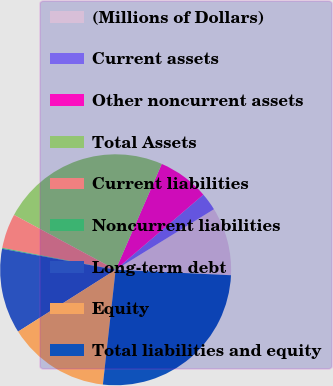Convert chart to OTSL. <chart><loc_0><loc_0><loc_500><loc_500><pie_chart><fcel>(Millions of Dollars)<fcel>Current assets<fcel>Other noncurrent assets<fcel>Total Assets<fcel>Current liabilities<fcel>Noncurrent liabilities<fcel>Long-term debt<fcel>Equity<fcel>Total liabilities and equity<nl><fcel>9.54%<fcel>2.48%<fcel>7.19%<fcel>23.66%<fcel>4.84%<fcel>0.13%<fcel>11.9%<fcel>14.25%<fcel>26.01%<nl></chart> 